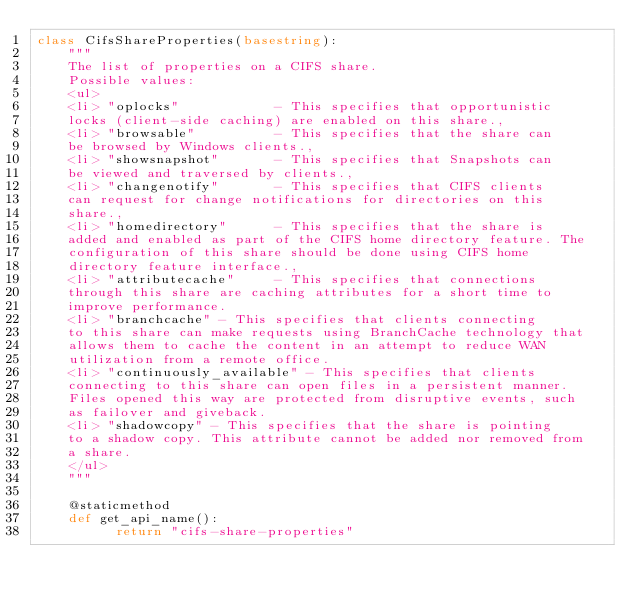Convert code to text. <code><loc_0><loc_0><loc_500><loc_500><_Python_>class CifsShareProperties(basestring):
    """
    The list of properties on a CIFS share.
    Possible values:
    <ul>
    <li> "oplocks"            - This specifies that opportunistic
    locks (client-side caching) are enabled on this share.,
    <li> "browsable"          - This specifies that the share can
    be browsed by Windows clients.,
    <li> "showsnapshot"       - This specifies that Snapshots can
    be viewed and traversed by clients.,
    <li> "changenotify"       - This specifies that CIFS clients
    can request for change notifications for directories on this
    share.,
    <li> "homedirectory"      - This specifies that the share is
    added and enabled as part of the CIFS home directory feature. The
    configuration of this share should be done using CIFS home
    directory feature interface.,
    <li> "attributecache"     - This specifies that connections
    through this share are caching attributes for a short time to
    improve performance.
    <li> "branchcache" - This specifies that clients connecting
    to this share can make requests using BranchCache technology that
    allows them to cache the content in an attempt to reduce WAN
    utilization from a remote office.
    <li> "continuously_available" - This specifies that clients
    connecting to this share can open files in a persistent manner.
    Files opened this way are protected from disruptive events, such
    as failover and giveback.
    <li> "shadowcopy" - This specifies that the share is pointing
    to a shadow copy. This attribute cannot be added nor removed from
    a share.
    </ul>
    """
    
    @staticmethod
    def get_api_name():
          return "cifs-share-properties"
    
</code> 